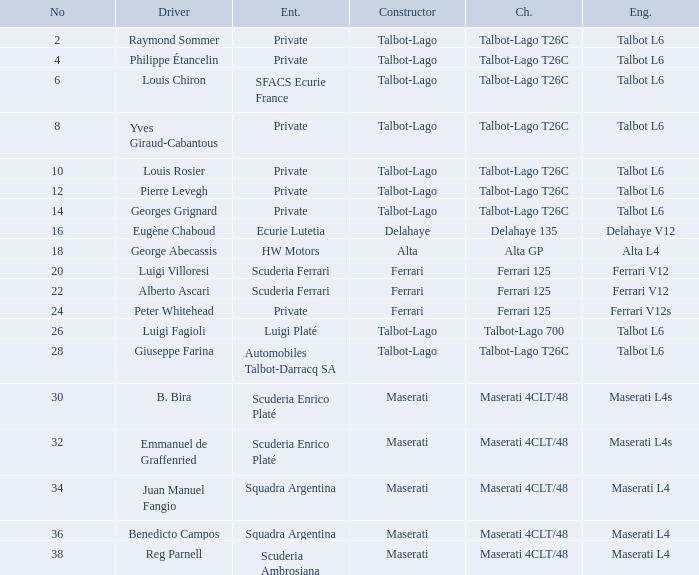Identify the frame for sfacs ecurie france Talbot-Lago T26C. 